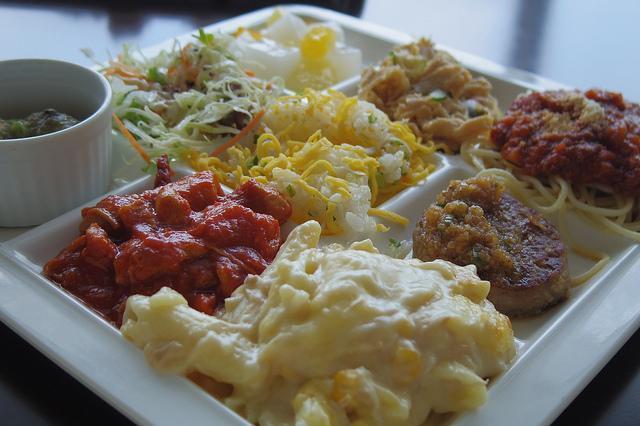How many foods are seen?
Give a very brief answer. 9. How many men are there?
Give a very brief answer. 0. 